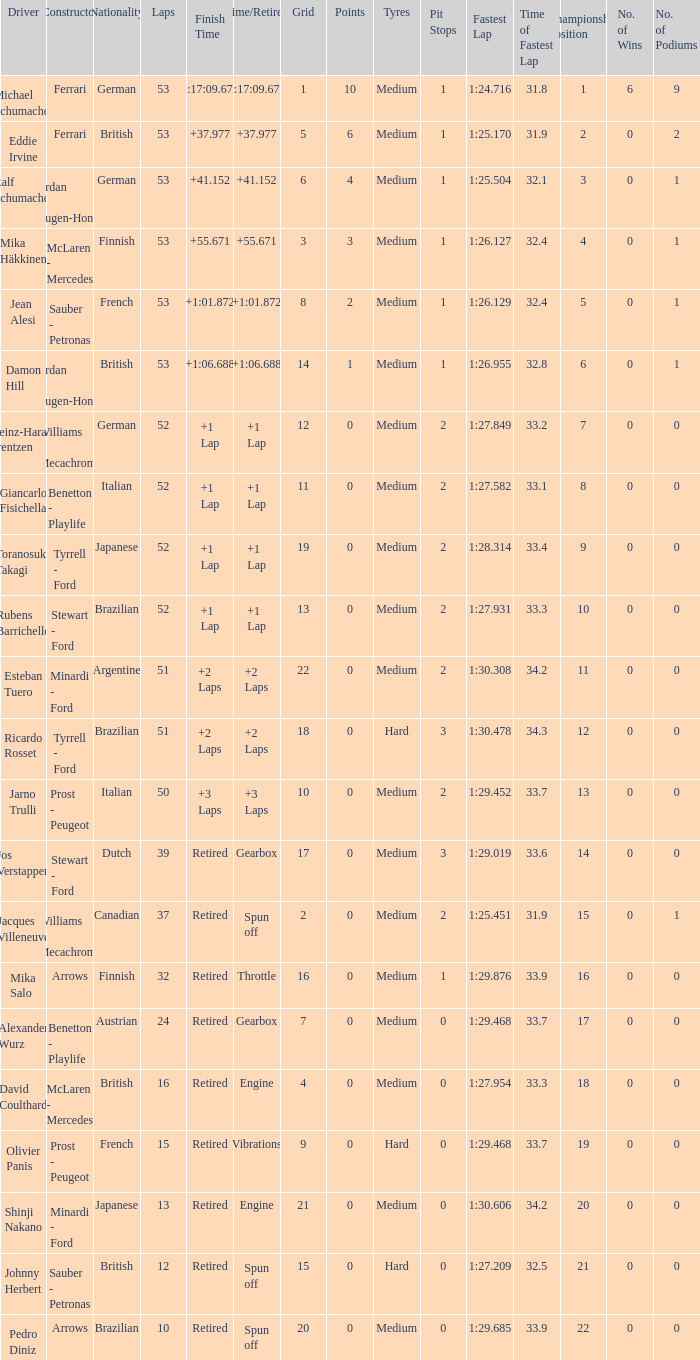Who built the car that went 53 laps with a Time/Retired of 1:17:09.672? Ferrari. Help me parse the entirety of this table. {'header': ['Driver', 'Constructor', 'Nationality', 'Laps', 'Finish Time', 'Time/Retired', 'Grid', 'Points', 'Tyres', 'Pit Stops', 'Fastest Lap', 'Time of Fastest Lap', 'Championship Position', 'No. of Wins', 'No. of Podiums'], 'rows': [['Michael Schumacher', 'Ferrari', 'German', '53', '1:17:09.672', '1:17:09.672', '1', '10', 'Medium', '1', '1:24.716', '31.8', '1', '6', '9'], ['Eddie Irvine', 'Ferrari', 'British', '53', '+37.977', '+37.977', '5', '6', 'Medium', '1', '1:25.170', '31.9', '2', '0', '2'], ['Ralf Schumacher', 'Jordan - Mugen-Honda', 'German', '53', '+41.152', '+41.152', '6', '4', 'Medium', '1', '1:25.504', '32.1', '3', '0', '1'], ['Mika Häkkinen', 'McLaren - Mercedes', 'Finnish', '53', '+55.671', '+55.671', '3', '3', 'Medium', '1', '1:26.127', '32.4', '4', '0', '1'], ['Jean Alesi', 'Sauber - Petronas', 'French', '53', '+1:01.872', '+1:01.872', '8', '2', 'Medium', '1', '1:26.129', '32.4', '5', '0', '1'], ['Damon Hill', 'Jordan - Mugen-Honda', 'British', '53', '+1:06.688', '+1:06.688', '14', '1', 'Medium', '1', '1:26.955', '32.8', '6', '0', '1'], ['Heinz-Harald Frentzen', 'Williams - Mecachrome', 'German', '52', '+1 Lap', '+1 Lap', '12', '0', 'Medium', '2', '1:27.849', '33.2', '7', '0', '0'], ['Giancarlo Fisichella', 'Benetton - Playlife', 'Italian', '52', '+1 Lap', '+1 Lap', '11', '0', 'Medium', '2', '1:27.582', '33.1', '8', '0', '0'], ['Toranosuke Takagi', 'Tyrrell - Ford', 'Japanese', '52', '+1 Lap', '+1 Lap', '19', '0', 'Medium', '2', '1:28.314', '33.4', '9', '0', '0'], ['Rubens Barrichello', 'Stewart - Ford', 'Brazilian', '52', '+1 Lap', '+1 Lap', '13', '0', 'Medium', '2', '1:27.931', '33.3', '10', '0', '0'], ['Esteban Tuero', 'Minardi - Ford', 'Argentine', '51', '+2 Laps', '+2 Laps', '22', '0', 'Medium', '2', '1:30.308', '34.2', '11', '0', '0'], ['Ricardo Rosset', 'Tyrrell - Ford', 'Brazilian', '51', '+2 Laps', '+2 Laps', '18', '0', 'Hard', '3', '1:30.478', '34.3', '12', '0', '0'], ['Jarno Trulli', 'Prost - Peugeot', 'Italian', '50', '+3 Laps', '+3 Laps', '10', '0', 'Medium', '2', '1:29.452', '33.7', '13', '0', '0'], ['Jos Verstappen', 'Stewart - Ford', 'Dutch', '39', 'Retired', 'Gearbox', '17', '0', 'Medium', '3', '1:29.019', '33.6', '14', '0', '0'], ['Jacques Villeneuve', 'Williams - Mecachrome', 'Canadian', '37', 'Retired', 'Spun off', '2', '0', 'Medium', '2', '1:25.451', '31.9', '15', '0', '1'], ['Mika Salo', 'Arrows', 'Finnish', '32', 'Retired', 'Throttle', '16', '0', 'Medium', '1', '1:29.876', '33.9', '16', '0', '0'], ['Alexander Wurz', 'Benetton - Playlife', 'Austrian', '24', 'Retired', 'Gearbox', '7', '0', 'Medium', '0', '1:29.468', '33.7', '17', '0', '0'], ['David Coulthard', 'McLaren - Mercedes', 'British', '16', 'Retired', 'Engine', '4', '0', 'Medium', '0', '1:27.954', '33.3', '18', '0', '0'], ['Olivier Panis', 'Prost - Peugeot', 'French', '15', 'Retired', 'Vibrations', '9', '0', 'Hard', '0', '1:29.468', '33.7', '19', '0', '0'], ['Shinji Nakano', 'Minardi - Ford', 'Japanese', '13', 'Retired', 'Engine', '21', '0', 'Medium', '0', '1:30.606', '34.2', '20', '0', '0'], ['Johnny Herbert', 'Sauber - Petronas', 'British', '12', 'Retired', 'Spun off', '15', '0', 'Hard', '0', '1:27.209', '32.5', '21', '0', '0'], ['Pedro Diniz', 'Arrows', 'Brazilian', '10', 'Retired', 'Spun off', '20', '0', 'Medium', '0', '1:29.685', '33.9', '22', '0', '0']]} 